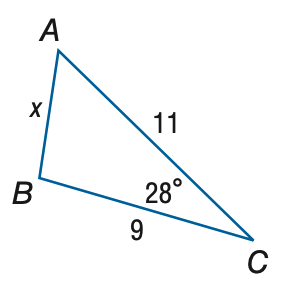Answer the mathemtical geometry problem and directly provide the correct option letter.
Question: Find x. Round to the nearest tenth.
Choices: A: 2.6 B: 5.2 C: 10.4 D: 27.2 B 